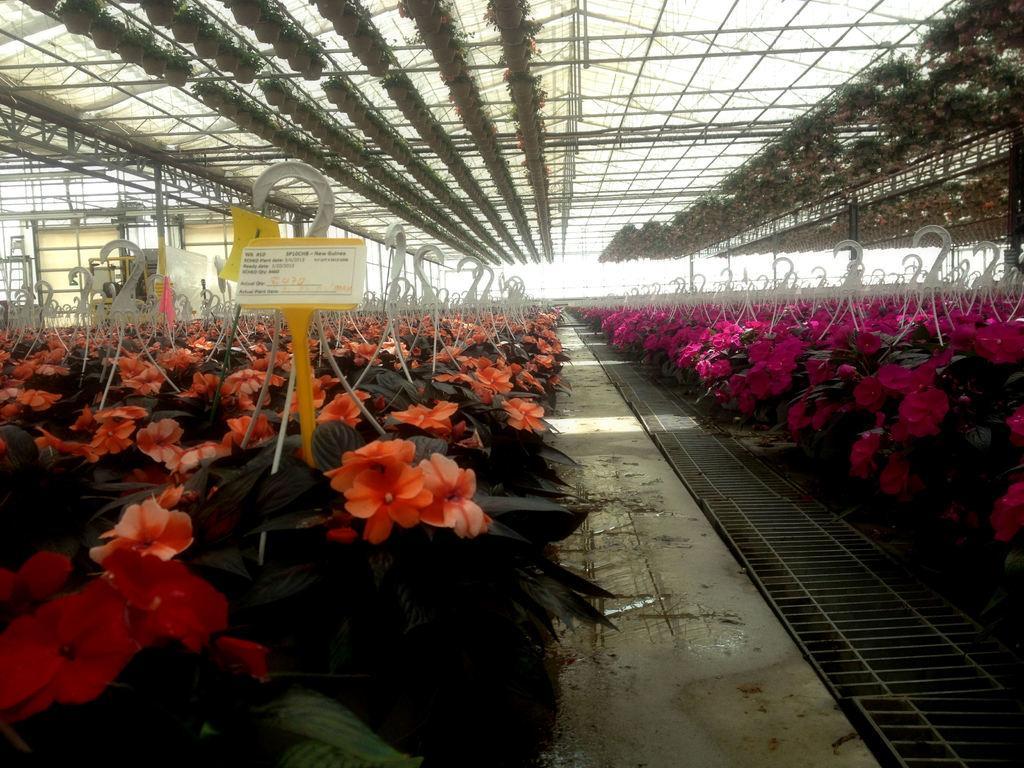In one or two sentences, can you explain what this image depicts? On the right and left of the image we can see plants and flowers. In the center of the image we can see walk way. At the top of the image we can see house plants. 